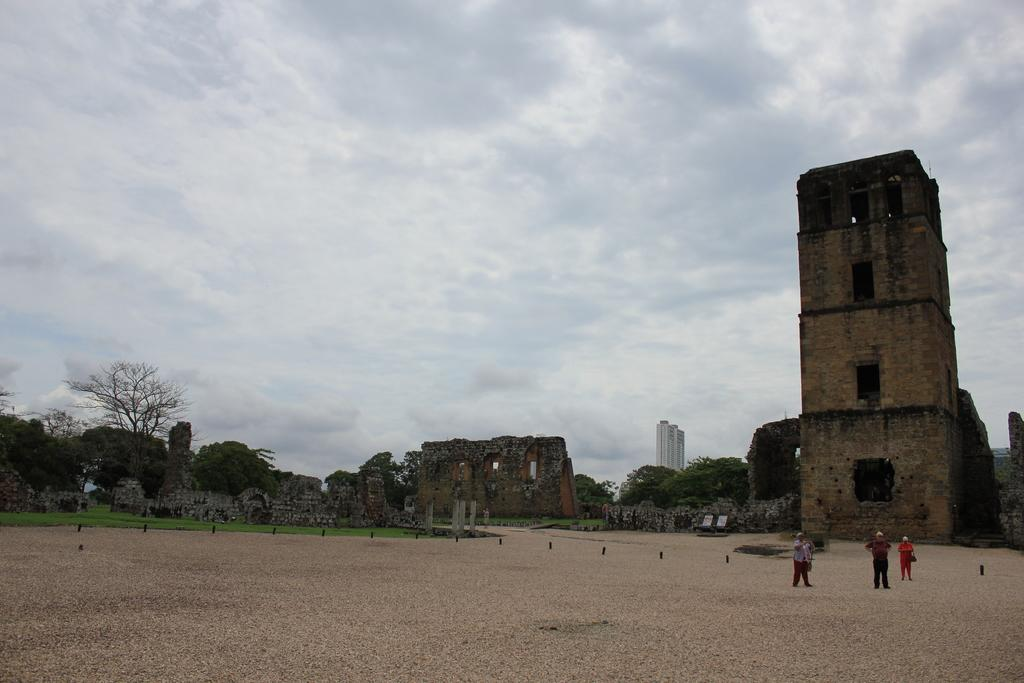What is happening in the image involving people? There is a group of people standing in the image. What can be seen in the background of the image? There are buildings in the background of the image. What colors are the buildings? The buildings are in cream and white colors. What is visible above the buildings? The sky is visible in the image. What color is the sky? The sky is in a white color. Are there any flowers growing in the image? There is no mention of flowers in the image, so we cannot determine if any are present. 